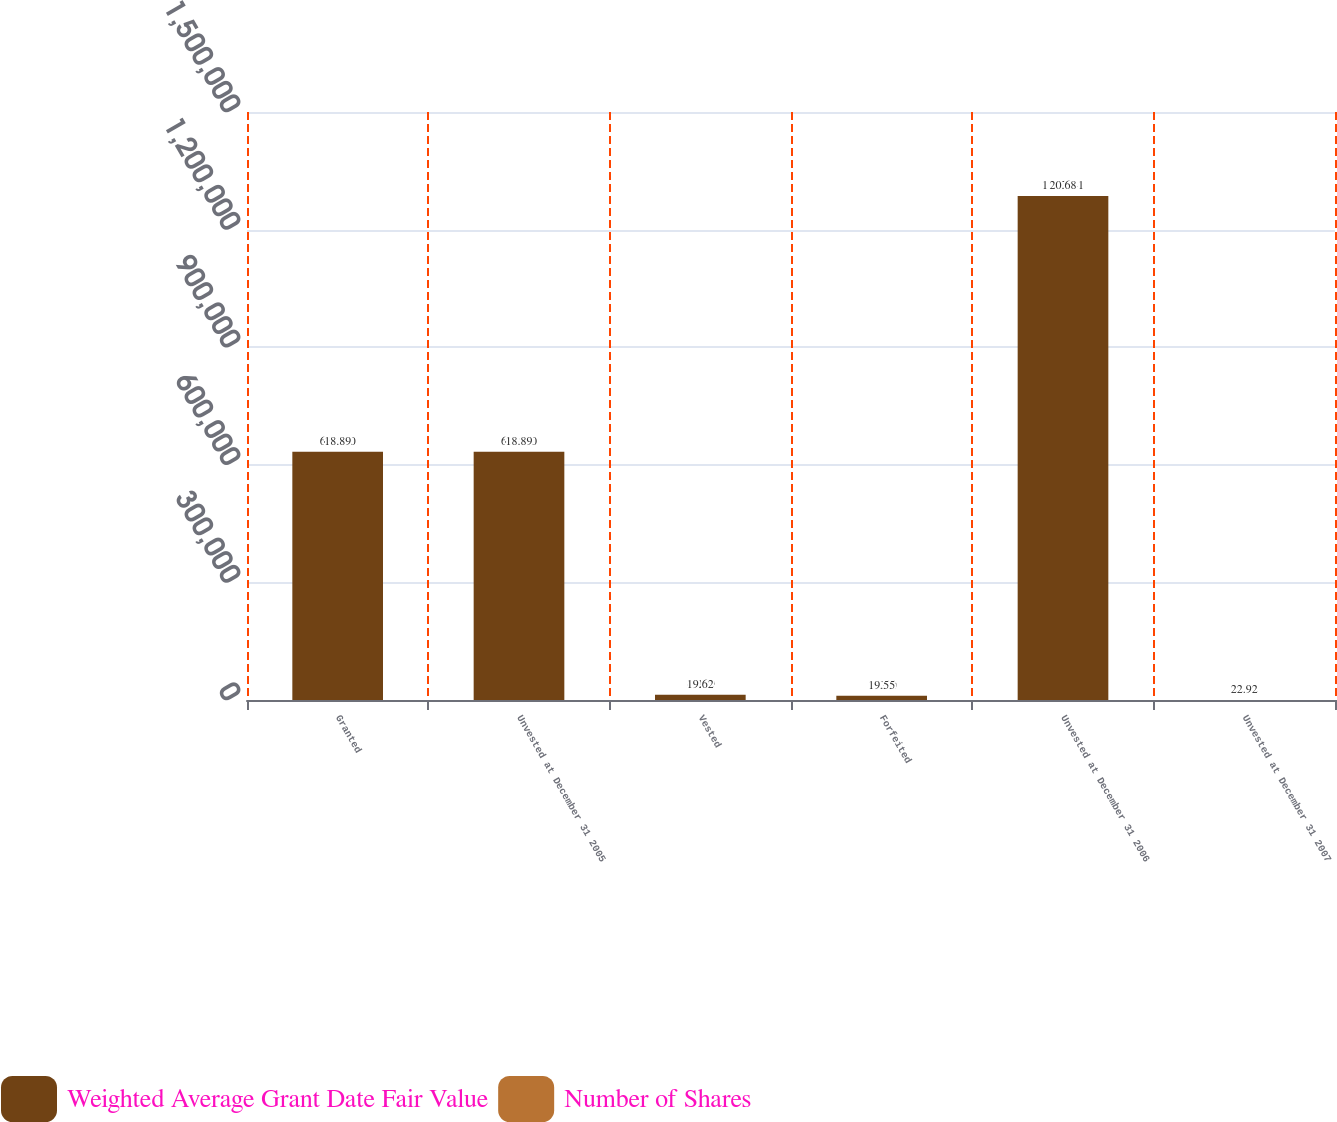<chart> <loc_0><loc_0><loc_500><loc_500><stacked_bar_chart><ecel><fcel>Granted<fcel>Unvested at December 31 2005<fcel>Vested<fcel>Forfeited<fcel>Unvested at December 31 2006<fcel>Unvested at December 31 2007<nl><fcel>Weighted Average Grant Date Fair Value<fcel>633200<fcel>633200<fcel>13119<fcel>11060<fcel>1.28574e+06<fcel>22.92<nl><fcel>Number of Shares<fcel>18.89<fcel>18.89<fcel>19.62<fcel>19.55<fcel>20.68<fcel>22.92<nl></chart> 